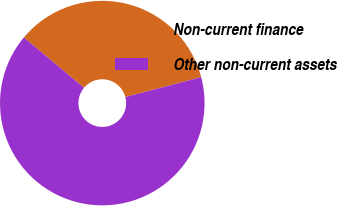Convert chart to OTSL. <chart><loc_0><loc_0><loc_500><loc_500><pie_chart><fcel>Non-current finance<fcel>Other non-current assets<nl><fcel>34.82%<fcel>65.18%<nl></chart> 